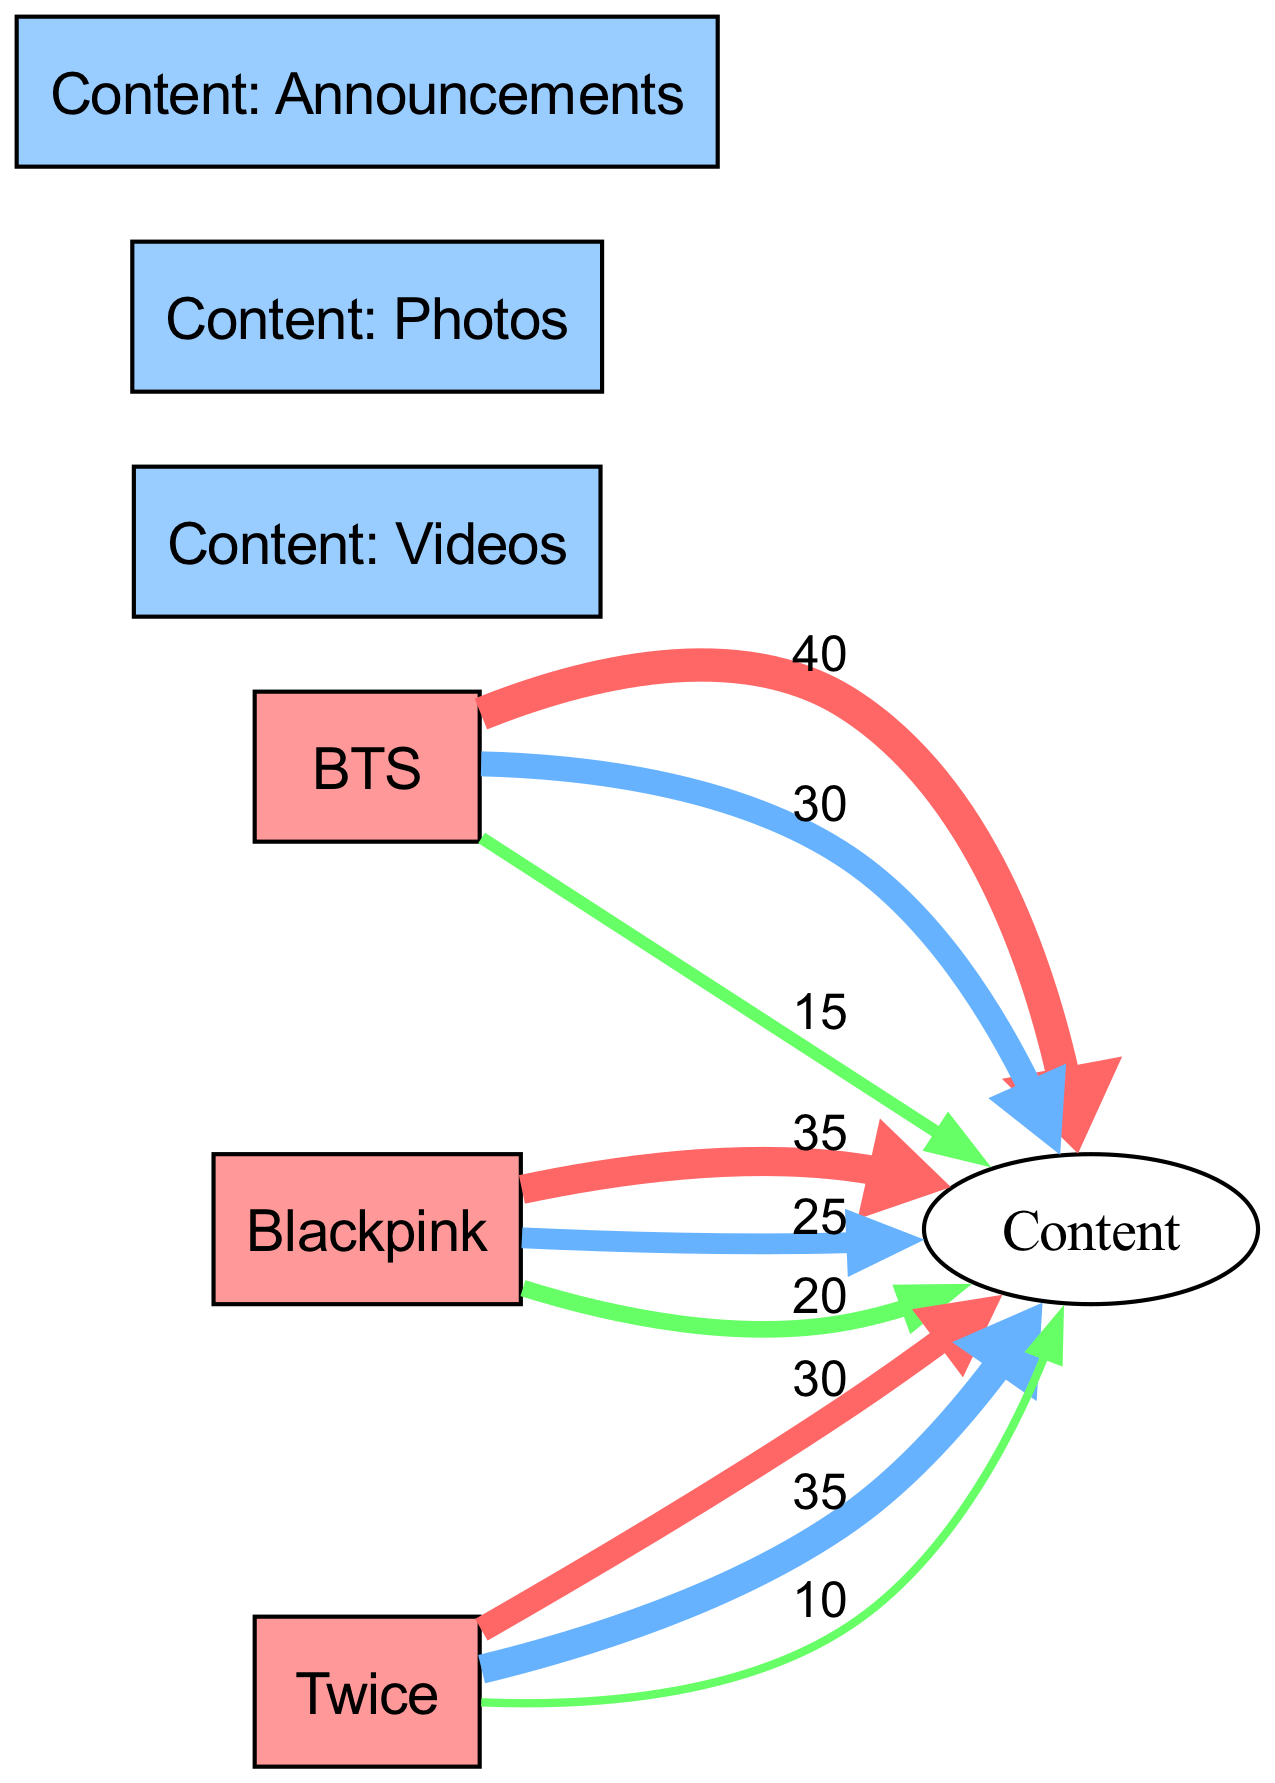What is the total engagement value for BTS's photos? The engagement value for BTS's photos is indicated by the link between the BTS node and the Content: Photos node, which shows a value of 30.
Answer: 30 Which K-pop band has the highest engagement for announcements? To find the band with the highest engagement for announcements, we compare the values linked to the Content: Announcements node. BTS has 15, Blackpink has 20, and Twice has 10. Blackpink has the highest engagement with a value of 20.
Answer: Blackpink How many content types are represented in the diagram? The diagram shows three content types: Videos, Photos, and Announcements. This can be counted by listing the nodes categorized as content.
Answer: 3 What is the total engagement value for Twice's videos and photos combined? To find the total engagement for Twice, we sum the values linked to Twice for both videos and photos. The value for videos is 30, and for photos is 35. Adding these gives 30 + 35 = 65.
Answer: 65 Which content type receives the most engagement from BTS? The highest engagement value for BTS can be found in the links to the content types. BTS has 40 for videos, 30 for photos, and 15 for announcements. The highest is 40 for videos.
Answer: Videos What is the engagement value for Blackpink's videos? The engagement value for Blackpink's videos is directly indicated by the link from Blackpink to Content: Videos, which shows a value of 35.
Answer: 35 Which K-pop band has the lowest total engagement across all content types? To find the band with the lowest total engagement, we add up each band's engagement values: BTS (40 + 30 + 15 = 85), Blackpink (35 + 25 + 20 = 80), Twice (30 + 35 + 10 = 75). Twice has the lowest total engagement of 75.
Answer: Twice What is the difference in engagement for photos between BTS and Twice? To find the difference in engagement for photos, we look at the values: BTS has 30 for photos, and Twice has 35. The difference is calculated as 35 - 30 = 5.
Answer: 5 Which content type has the highest overall engagement across all bands? We can find the overall engagement for each content type by summing their engagement values across all bands: Videos (40 + 35 + 30 = 105), Photos (30 + 25 + 35 = 90), Announcements (15 + 20 + 10 = 45). Videos has the highest overall engagement of 105.
Answer: Videos 